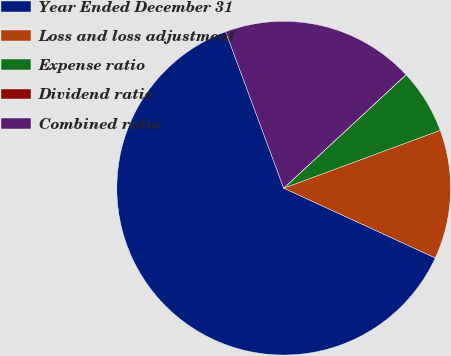Convert chart. <chart><loc_0><loc_0><loc_500><loc_500><pie_chart><fcel>Year Ended December 31<fcel>Loss and loss adjustment<fcel>Expense ratio<fcel>Dividend ratio<fcel>Combined ratio<nl><fcel>62.48%<fcel>12.5%<fcel>6.26%<fcel>0.01%<fcel>18.75%<nl></chart> 